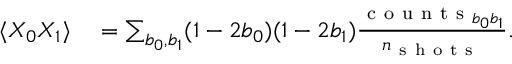Convert formula to latex. <formula><loc_0><loc_0><loc_500><loc_500>\begin{array} { r l } { \langle X _ { 0 } X _ { 1 } \rangle } & = \sum _ { b _ { 0 } , b _ { 1 } } ( 1 - 2 b _ { 0 } ) ( 1 - 2 b _ { 1 } ) \frac { c o u n t s _ { b _ { 0 } b _ { 1 } } } { n _ { s h o t s } } . } \end{array}</formula> 